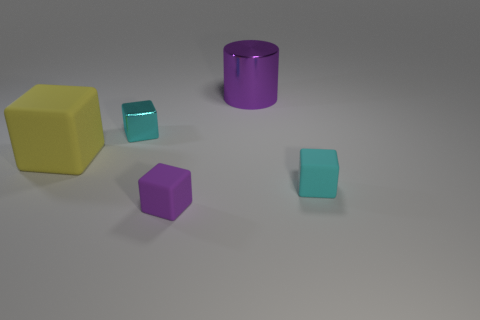Subtract 1 cubes. How many cubes are left? 3 Subtract all red blocks. Subtract all yellow cylinders. How many blocks are left? 4 Add 1 big purple metallic cylinders. How many objects exist? 6 Subtract all cubes. How many objects are left? 1 Add 1 small purple blocks. How many small purple blocks are left? 2 Add 2 large gray metallic objects. How many large gray metallic objects exist? 2 Subtract 0 yellow spheres. How many objects are left? 5 Subtract all metal objects. Subtract all cyan rubber blocks. How many objects are left? 2 